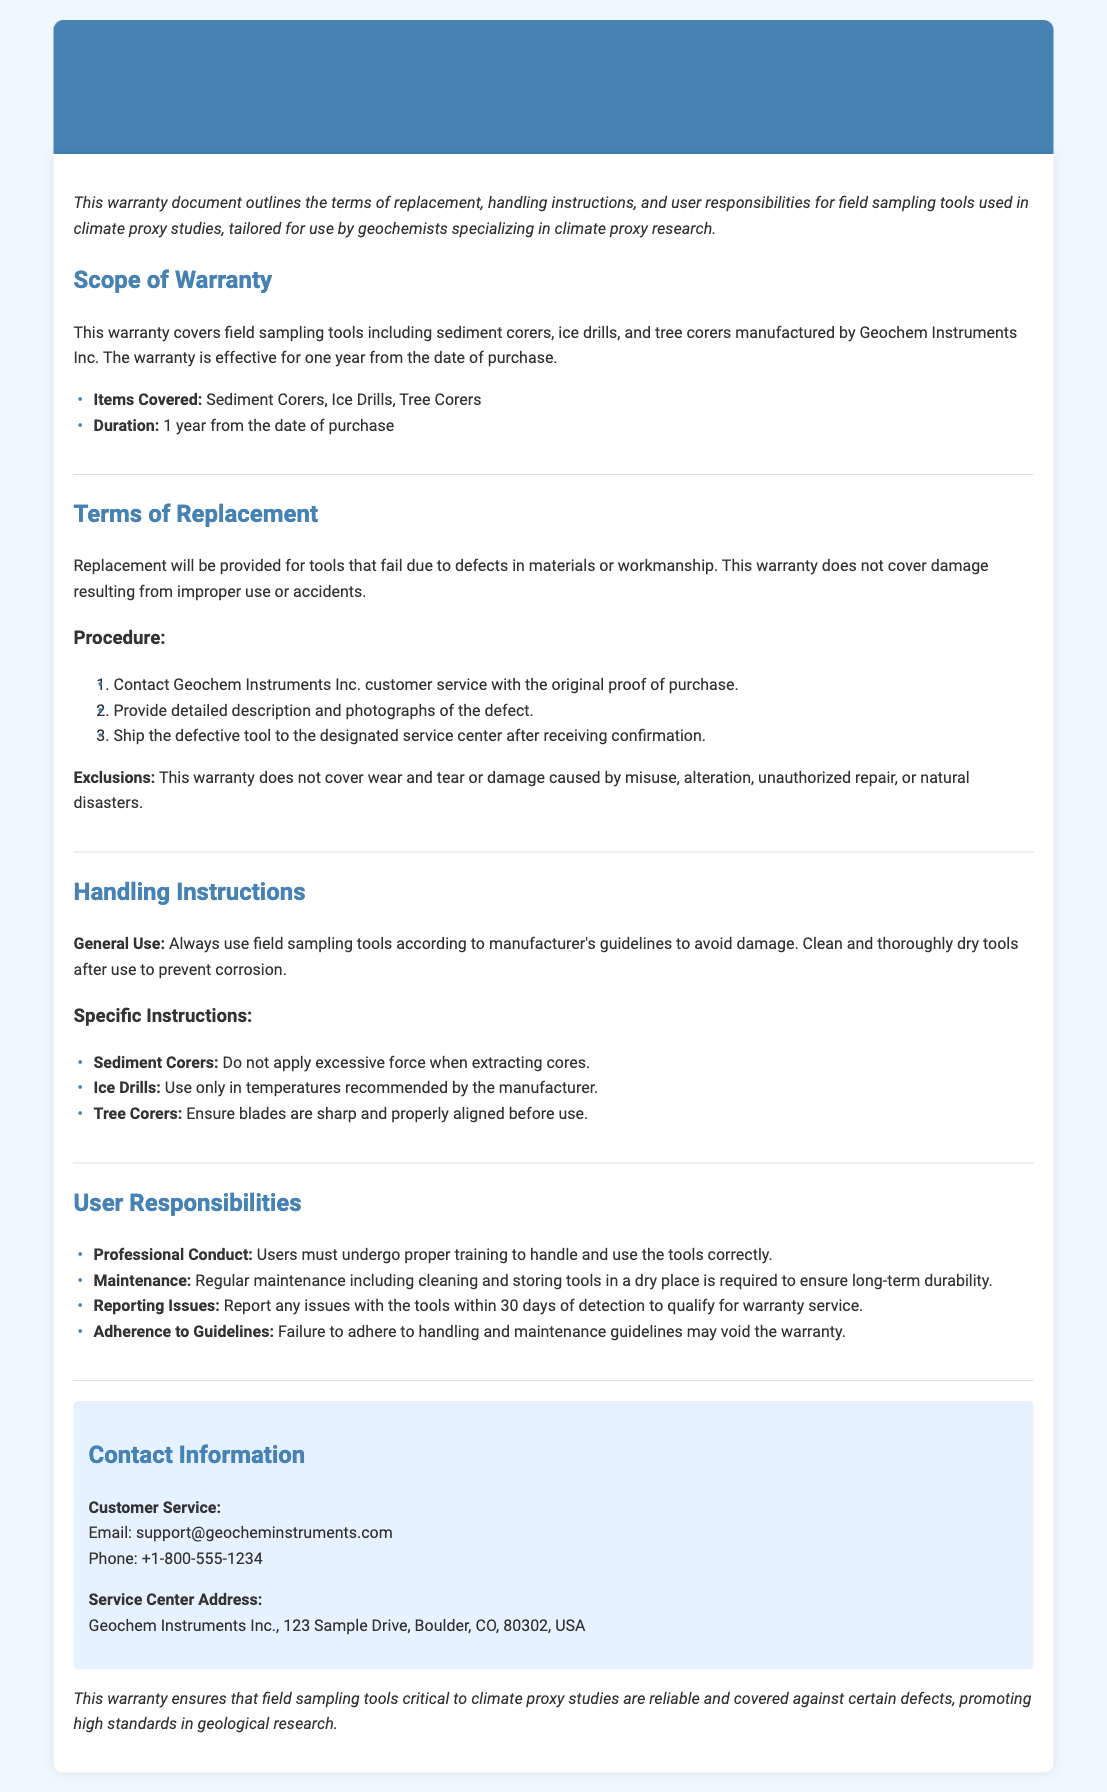What is the duration of the warranty? The warranty is effective for one year from the date of purchase.
Answer: 1 year What items are covered under this warranty? The items covered include sediment corers, ice drills, and tree corers.
Answer: Sediment Corers, Ice Drills, Tree Corers What must a user do to qualify for warranty service? Users must report any issues with the tools within 30 days of detection.
Answer: 30 days What is the first step in the replacement procedure? The first step is to contact Geochem Instruments Inc. customer service with the original proof of purchase.
Answer: Contact customer service One exclusion of the warranty is wear and tear. This warranty explicitly states that certain types of damage are not covered, such as wear and tear.
Answer: Wear and tear How should tools be maintained after use? Tools should be cleaned and thoroughly dried after use to prevent corrosion.
Answer: Clean and dry What type of training must users undergo? Users must undergo proper training to handle and use the tools correctly.
Answer: Proper training Where is the service center located? The address for the service center is included in the contact information section of the document.
Answer: 123 Sample Drive, Boulder, CO, 80302, USA 